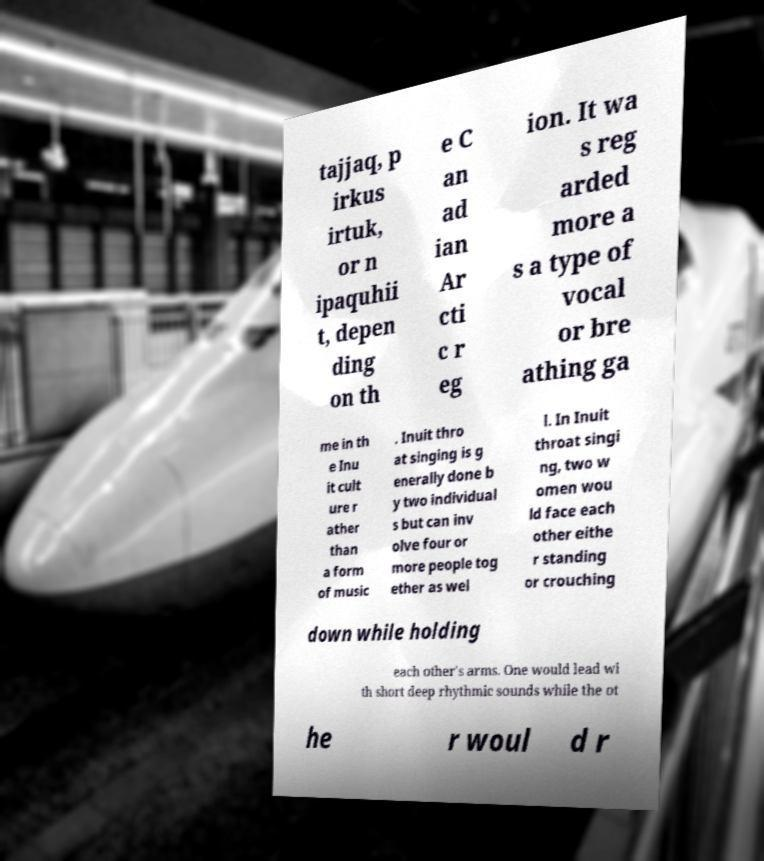For documentation purposes, I need the text within this image transcribed. Could you provide that? tajjaq, p irkus irtuk, or n ipaquhii t, depen ding on th e C an ad ian Ar cti c r eg ion. It wa s reg arded more a s a type of vocal or bre athing ga me in th e Inu it cult ure r ather than a form of music . Inuit thro at singing is g enerally done b y two individual s but can inv olve four or more people tog ether as wel l. In Inuit throat singi ng, two w omen wou ld face each other eithe r standing or crouching down while holding each other's arms. One would lead wi th short deep rhythmic sounds while the ot he r woul d r 